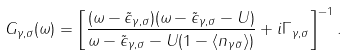Convert formula to latex. <formula><loc_0><loc_0><loc_500><loc_500>G _ { \gamma , \sigma } ( \omega ) = \left [ \frac { ( \omega - \tilde { \epsilon } _ { \gamma , \sigma } ) ( \omega - \tilde { \epsilon } _ { \gamma , \sigma } - U ) } { \omega - \tilde { \epsilon } _ { \gamma , \sigma } - U ( 1 - \langle n _ { \gamma \bar { \sigma } } \rangle ) } + i \Gamma _ { \gamma , \sigma } \right ] ^ { - 1 } .</formula> 